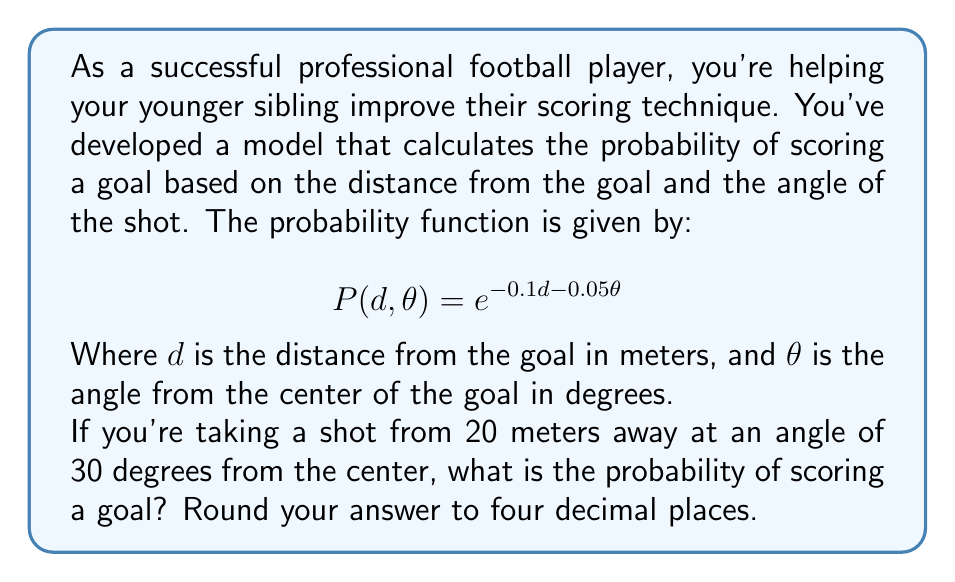Teach me how to tackle this problem. To solve this problem, we need to follow these steps:

1. Identify the given values:
   $d = 20$ meters (distance from the goal)
   $\theta = 30$ degrees (angle from the center of the goal)

2. Substitute these values into the probability function:
   $$P(d,\theta) = e^{-0.1d - 0.05\theta}$$
   $$P(20,30) = e^{-0.1(20) - 0.05(30)}$$

3. Simplify the exponent:
   $$P(20,30) = e^{-2 - 1.5}$$
   $$P(20,30) = e^{-3.5}$$

4. Calculate the value of $e^{-3.5}$:
   $$P(20,30) = 0.0301973834223185...$$

5. Round the result to four decimal places:
   $$P(20,30) \approx 0.0302$$

Therefore, the probability of scoring a goal from 20 meters away at an angle of 30 degrees is approximately 0.0302 or 3.02%.
Answer: 0.0302 